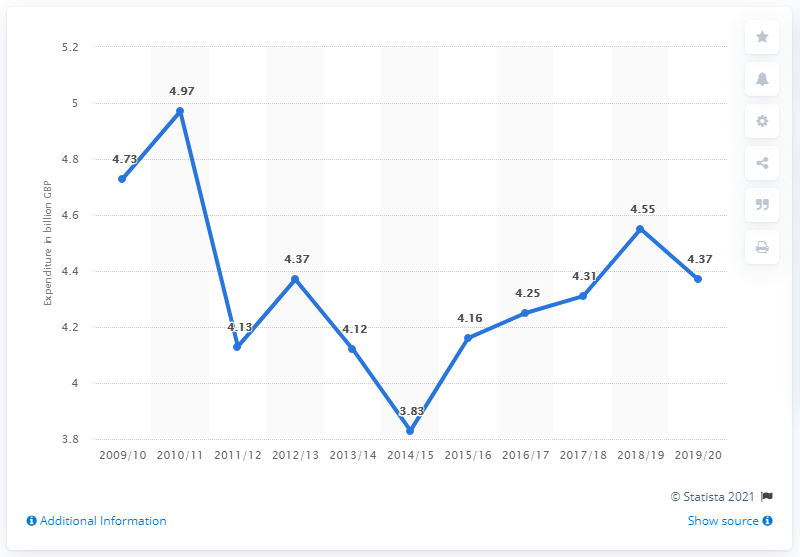Specify some key components in this picture. The United Kingdom (UK) spent 4.37 billion pounds on prisons in the 2019/20 fiscal year. The average public sector expenditure on prisons in the United Kingdom (UK) from 2018/19 to 2019/20 was 4.46. In the 2019/2020 fiscal year, the United Kingdom allocated 4.37 billion British pounds towards its prison system. 